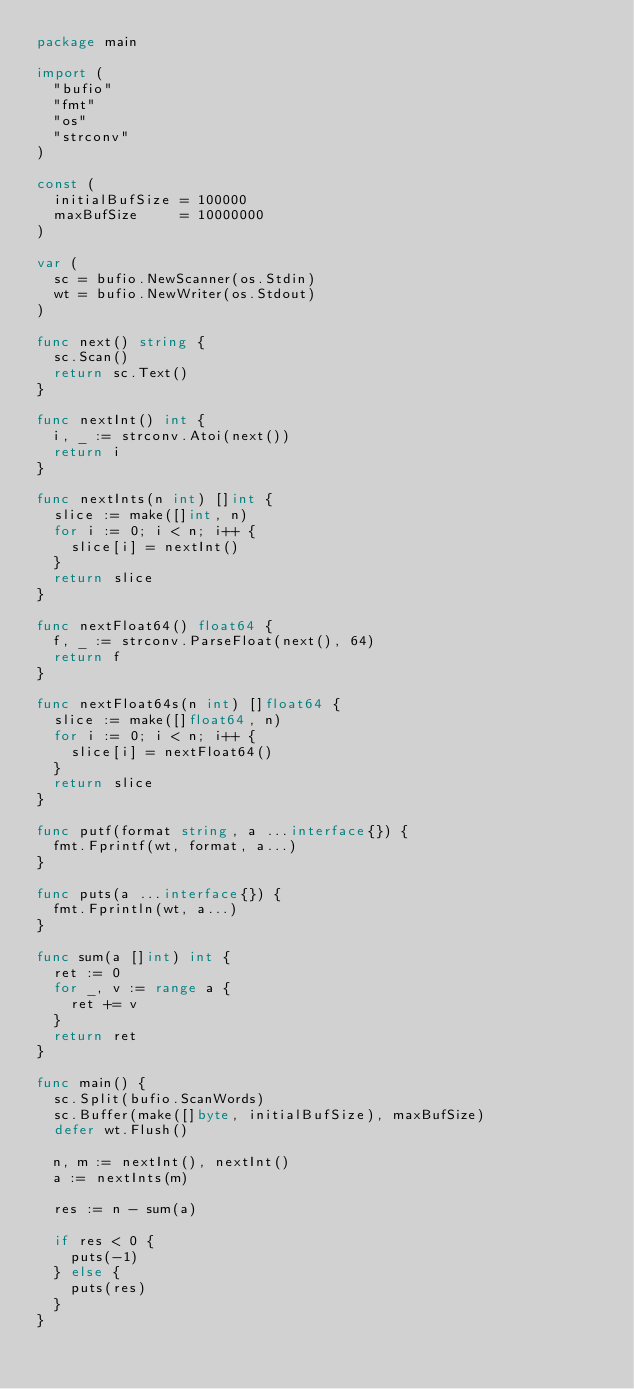<code> <loc_0><loc_0><loc_500><loc_500><_Go_>package main

import (
	"bufio"
	"fmt"
	"os"
	"strconv"
)

const (
	initialBufSize = 100000
	maxBufSize     = 10000000
)

var (
	sc = bufio.NewScanner(os.Stdin)
	wt = bufio.NewWriter(os.Stdout)
)

func next() string {
	sc.Scan()
	return sc.Text()
}

func nextInt() int {
	i, _ := strconv.Atoi(next())
	return i
}

func nextInts(n int) []int {
	slice := make([]int, n)
	for i := 0; i < n; i++ {
		slice[i] = nextInt()
	}
	return slice
}

func nextFloat64() float64 {
	f, _ := strconv.ParseFloat(next(), 64)
	return f
}

func nextFloat64s(n int) []float64 {
	slice := make([]float64, n)
	for i := 0; i < n; i++ {
		slice[i] = nextFloat64()
	}
	return slice
}

func putf(format string, a ...interface{}) {
	fmt.Fprintf(wt, format, a...)
}

func puts(a ...interface{}) {
	fmt.Fprintln(wt, a...)
}

func sum(a []int) int {
	ret := 0
	for _, v := range a {
		ret += v
	}
	return ret
}

func main() {
	sc.Split(bufio.ScanWords)
	sc.Buffer(make([]byte, initialBufSize), maxBufSize)
	defer wt.Flush()

	n, m := nextInt(), nextInt()
	a := nextInts(m)

	res := n - sum(a)

	if res < 0 {
		puts(-1)
	} else {
		puts(res)
	}
}
</code> 